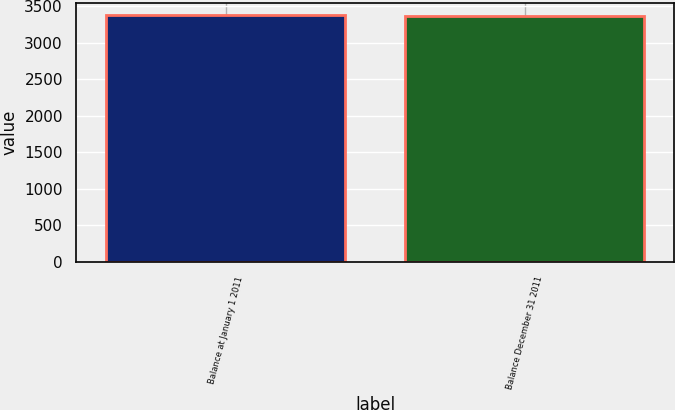Convert chart to OTSL. <chart><loc_0><loc_0><loc_500><loc_500><bar_chart><fcel>Balance at January 1 2011<fcel>Balance December 31 2011<nl><fcel>3381<fcel>3360<nl></chart> 